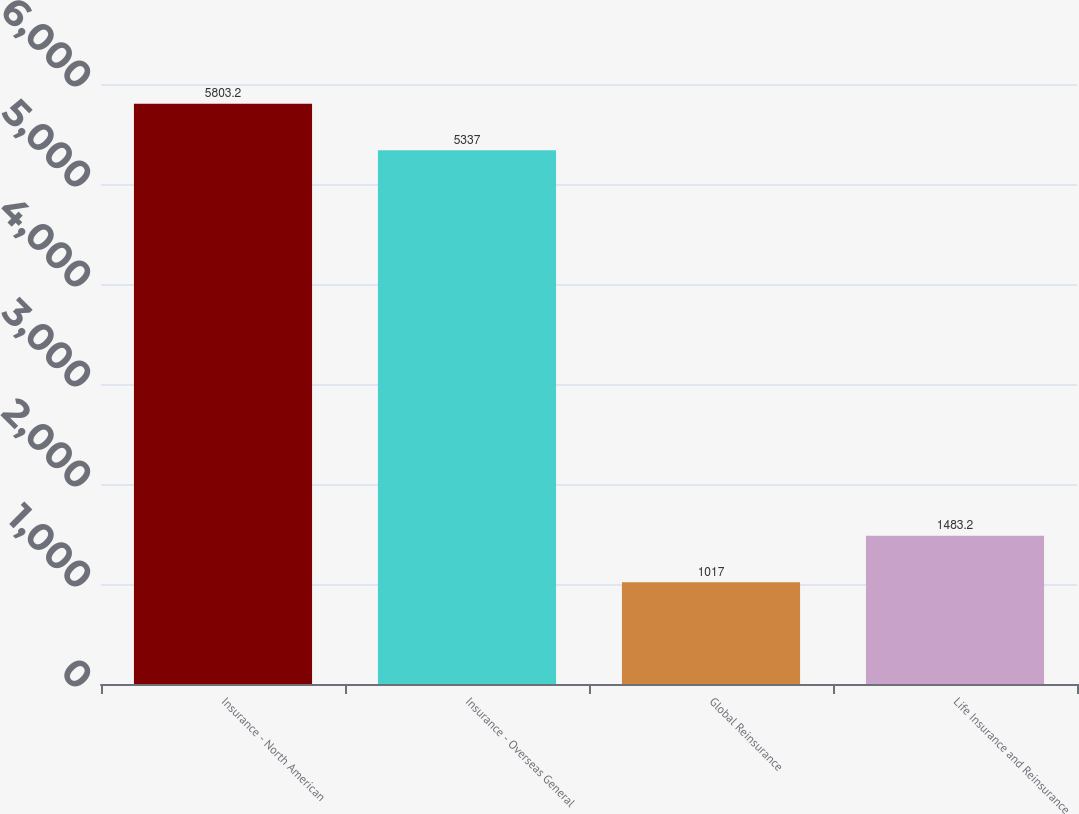<chart> <loc_0><loc_0><loc_500><loc_500><bar_chart><fcel>Insurance - North American<fcel>Insurance - Overseas General<fcel>Global Reinsurance<fcel>Life Insurance and Reinsurance<nl><fcel>5803.2<fcel>5337<fcel>1017<fcel>1483.2<nl></chart> 